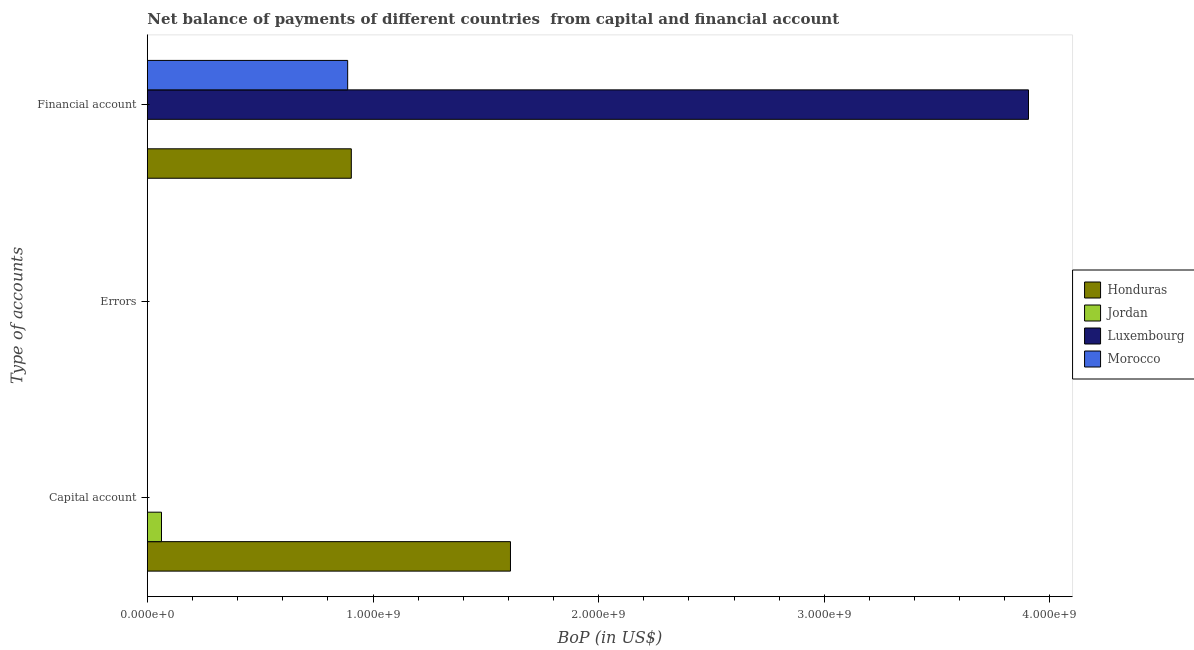Are the number of bars on each tick of the Y-axis equal?
Offer a very short reply. No. What is the label of the 3rd group of bars from the top?
Keep it short and to the point. Capital account. What is the amount of financial account in Morocco?
Keep it short and to the point. 8.88e+08. Across all countries, what is the maximum amount of financial account?
Offer a very short reply. 3.90e+09. In which country was the amount of financial account maximum?
Your answer should be very brief. Luxembourg. What is the total amount of net capital account in the graph?
Ensure brevity in your answer.  1.67e+09. What is the difference between the amount of financial account in Luxembourg and that in Honduras?
Make the answer very short. 3.00e+09. What is the difference between the amount of financial account in Luxembourg and the amount of errors in Honduras?
Provide a short and direct response. 3.90e+09. What is the average amount of financial account per country?
Ensure brevity in your answer.  1.42e+09. What is the ratio of the amount of financial account in Morocco to that in Honduras?
Your response must be concise. 0.98. How many countries are there in the graph?
Give a very brief answer. 4. What is the difference between two consecutive major ticks on the X-axis?
Your answer should be very brief. 1.00e+09. Does the graph contain any zero values?
Offer a very short reply. Yes. Where does the legend appear in the graph?
Offer a terse response. Center right. What is the title of the graph?
Offer a very short reply. Net balance of payments of different countries  from capital and financial account. What is the label or title of the X-axis?
Make the answer very short. BoP (in US$). What is the label or title of the Y-axis?
Your answer should be very brief. Type of accounts. What is the BoP (in US$) of Honduras in Capital account?
Your answer should be compact. 1.61e+09. What is the BoP (in US$) of Jordan in Capital account?
Ensure brevity in your answer.  6.28e+07. What is the BoP (in US$) of Luxembourg in Capital account?
Offer a terse response. 0. What is the BoP (in US$) of Morocco in Capital account?
Keep it short and to the point. 0. What is the BoP (in US$) in Luxembourg in Errors?
Provide a short and direct response. 0. What is the BoP (in US$) of Morocco in Errors?
Make the answer very short. 0. What is the BoP (in US$) in Honduras in Financial account?
Provide a short and direct response. 9.04e+08. What is the BoP (in US$) of Luxembourg in Financial account?
Make the answer very short. 3.90e+09. What is the BoP (in US$) in Morocco in Financial account?
Your answer should be very brief. 8.88e+08. Across all Type of accounts, what is the maximum BoP (in US$) of Honduras?
Offer a terse response. 1.61e+09. Across all Type of accounts, what is the maximum BoP (in US$) in Jordan?
Your answer should be very brief. 6.28e+07. Across all Type of accounts, what is the maximum BoP (in US$) in Luxembourg?
Your answer should be compact. 3.90e+09. Across all Type of accounts, what is the maximum BoP (in US$) of Morocco?
Offer a terse response. 8.88e+08. Across all Type of accounts, what is the minimum BoP (in US$) in Jordan?
Offer a terse response. 0. Across all Type of accounts, what is the minimum BoP (in US$) in Morocco?
Make the answer very short. 0. What is the total BoP (in US$) in Honduras in the graph?
Provide a succinct answer. 2.51e+09. What is the total BoP (in US$) of Jordan in the graph?
Your answer should be very brief. 6.28e+07. What is the total BoP (in US$) of Luxembourg in the graph?
Your response must be concise. 3.90e+09. What is the total BoP (in US$) in Morocco in the graph?
Keep it short and to the point. 8.88e+08. What is the difference between the BoP (in US$) of Honduras in Capital account and that in Financial account?
Keep it short and to the point. 7.05e+08. What is the difference between the BoP (in US$) of Honduras in Capital account and the BoP (in US$) of Luxembourg in Financial account?
Offer a terse response. -2.30e+09. What is the difference between the BoP (in US$) of Honduras in Capital account and the BoP (in US$) of Morocco in Financial account?
Provide a succinct answer. 7.22e+08. What is the difference between the BoP (in US$) of Jordan in Capital account and the BoP (in US$) of Luxembourg in Financial account?
Ensure brevity in your answer.  -3.84e+09. What is the difference between the BoP (in US$) of Jordan in Capital account and the BoP (in US$) of Morocco in Financial account?
Provide a short and direct response. -8.25e+08. What is the average BoP (in US$) in Honduras per Type of accounts?
Provide a short and direct response. 8.38e+08. What is the average BoP (in US$) in Jordan per Type of accounts?
Make the answer very short. 2.09e+07. What is the average BoP (in US$) of Luxembourg per Type of accounts?
Your response must be concise. 1.30e+09. What is the average BoP (in US$) of Morocco per Type of accounts?
Ensure brevity in your answer.  2.96e+08. What is the difference between the BoP (in US$) of Honduras and BoP (in US$) of Jordan in Capital account?
Offer a terse response. 1.55e+09. What is the difference between the BoP (in US$) in Honduras and BoP (in US$) in Luxembourg in Financial account?
Provide a succinct answer. -3.00e+09. What is the difference between the BoP (in US$) of Honduras and BoP (in US$) of Morocco in Financial account?
Your answer should be compact. 1.62e+07. What is the difference between the BoP (in US$) in Luxembourg and BoP (in US$) in Morocco in Financial account?
Your answer should be very brief. 3.02e+09. What is the ratio of the BoP (in US$) of Honduras in Capital account to that in Financial account?
Your answer should be compact. 1.78. What is the difference between the highest and the lowest BoP (in US$) of Honduras?
Ensure brevity in your answer.  1.61e+09. What is the difference between the highest and the lowest BoP (in US$) of Jordan?
Offer a terse response. 6.28e+07. What is the difference between the highest and the lowest BoP (in US$) in Luxembourg?
Provide a succinct answer. 3.90e+09. What is the difference between the highest and the lowest BoP (in US$) of Morocco?
Ensure brevity in your answer.  8.88e+08. 